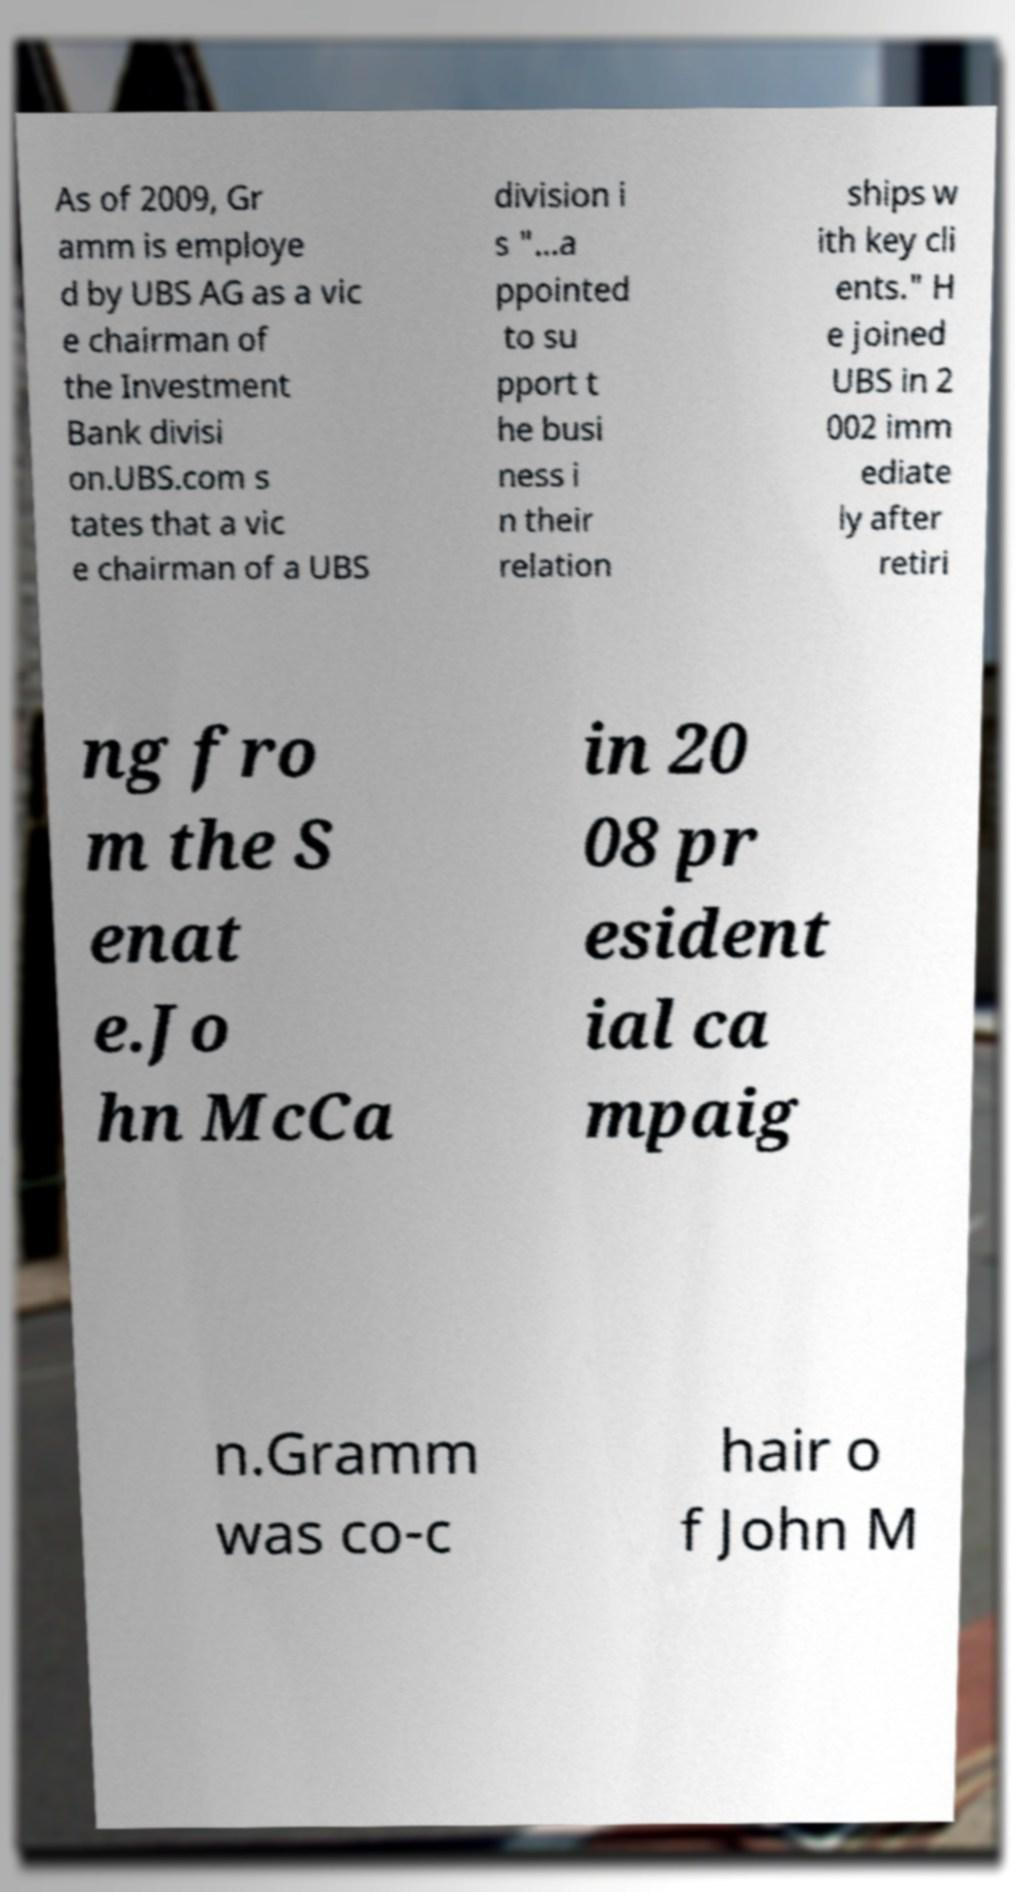Can you accurately transcribe the text from the provided image for me? As of 2009, Gr amm is employe d by UBS AG as a vic e chairman of the Investment Bank divisi on.UBS.com s tates that a vic e chairman of a UBS division i s "...a ppointed to su pport t he busi ness i n their relation ships w ith key cli ents." H e joined UBS in 2 002 imm ediate ly after retiri ng fro m the S enat e.Jo hn McCa in 20 08 pr esident ial ca mpaig n.Gramm was co-c hair o f John M 